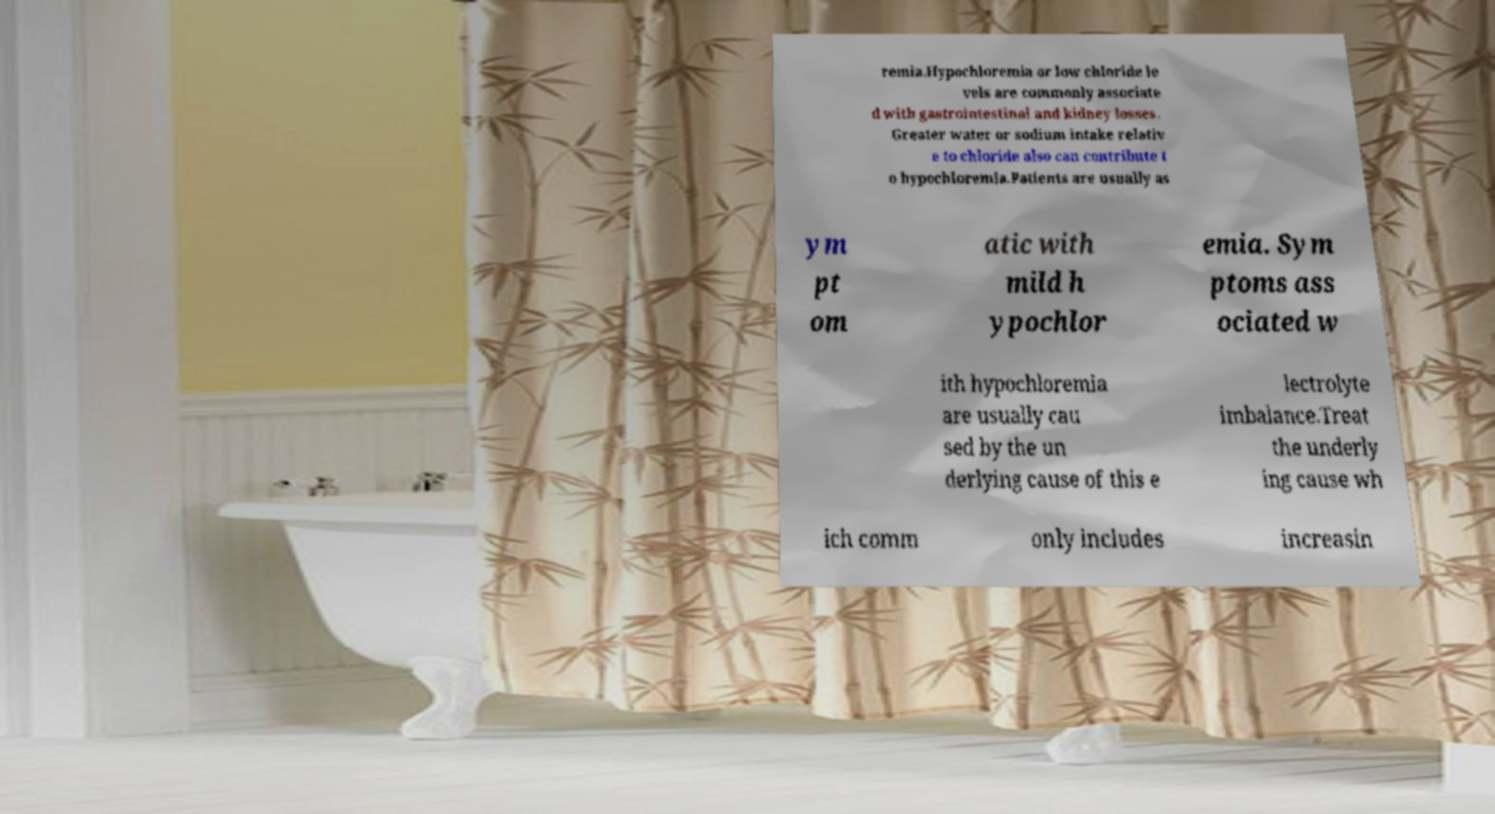Please identify and transcribe the text found in this image. remia.Hypochloremia or low chloride le vels are commonly associate d with gastrointestinal and kidney losses. Greater water or sodium intake relativ e to chloride also can contribute t o hypochloremia.Patients are usually as ym pt om atic with mild h ypochlor emia. Sym ptoms ass ociated w ith hypochloremia are usually cau sed by the un derlying cause of this e lectrolyte imbalance.Treat the underly ing cause wh ich comm only includes increasin 